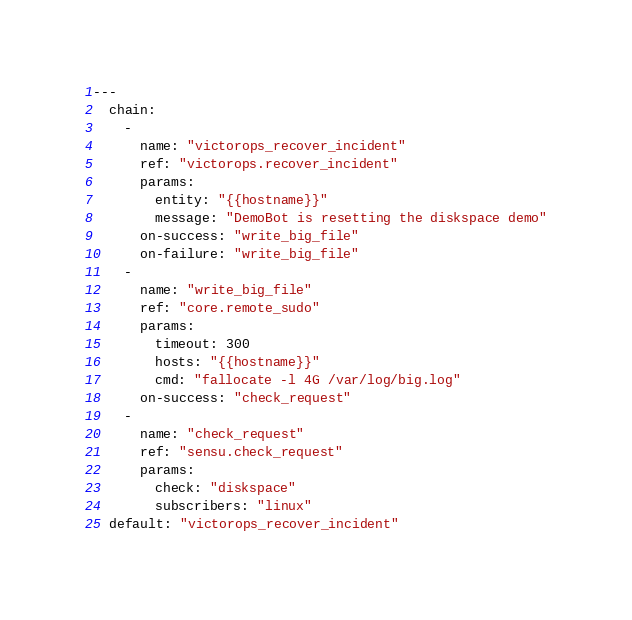Convert code to text. <code><loc_0><loc_0><loc_500><loc_500><_YAML_>---
  chain:
    -
      name: "victorops_recover_incident"
      ref: "victorops.recover_incident"
      params:
        entity: "{{hostname}}"
        message: "DemoBot is resetting the diskspace demo"
      on-success: "write_big_file"
      on-failure: "write_big_file"
    -
      name: "write_big_file"
      ref: "core.remote_sudo"
      params:
        timeout: 300
        hosts: "{{hostname}}"
        cmd: "fallocate -l 4G /var/log/big.log"
      on-success: "check_request"
    -
      name: "check_request"
      ref: "sensu.check_request"
      params:
        check: "diskspace"
        subscribers: "linux"
  default: "victorops_recover_incident"
</code> 